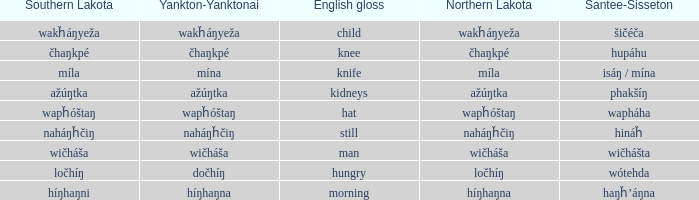Name the southern lakota for híŋhaŋna Híŋhaŋni. 